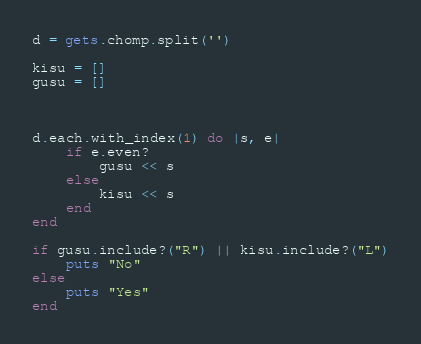<code> <loc_0><loc_0><loc_500><loc_500><_Ruby_>d = gets.chomp.split('')

kisu = []
gusu = []



d.each.with_index(1) do |s, e|
	if e.even?
		gusu << s
	else
		kisu << s
	end
end

if gusu.include?("R") || kisu.include?("L")
	puts "No"
else
	puts "Yes"
end</code> 